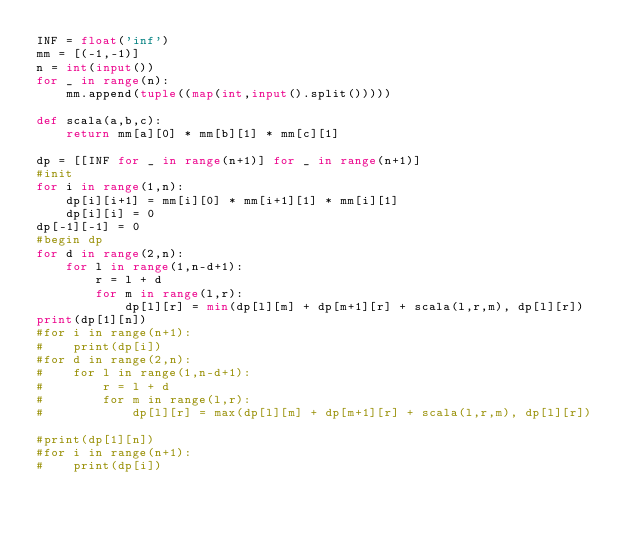<code> <loc_0><loc_0><loc_500><loc_500><_Python_>INF = float('inf')
mm = [(-1,-1)]
n = int(input())
for _ in range(n):
    mm.append(tuple((map(int,input().split()))))

def scala(a,b,c):
    return mm[a][0] * mm[b][1] * mm[c][1] 

dp = [[INF for _ in range(n+1)] for _ in range(n+1)]
#init
for i in range(1,n):
    dp[i][i+1] = mm[i][0] * mm[i+1][1] * mm[i][1]
    dp[i][i] = 0
dp[-1][-1] = 0
#begin dp
for d in range(2,n):
    for l in range(1,n-d+1):
        r = l + d
        for m in range(l,r):
            dp[l][r] = min(dp[l][m] + dp[m+1][r] + scala(l,r,m), dp[l][r])
print(dp[1][n])
#for i in range(n+1):
#    print(dp[i])
#for d in range(2,n):
#    for l in range(1,n-d+1):
#        r = l + d
#        for m in range(l,r):
#            dp[l][r] = max(dp[l][m] + dp[m+1][r] + scala(l,r,m), dp[l][r])

#print(dp[1][n])
#for i in range(n+1):
#    print(dp[i])

</code> 